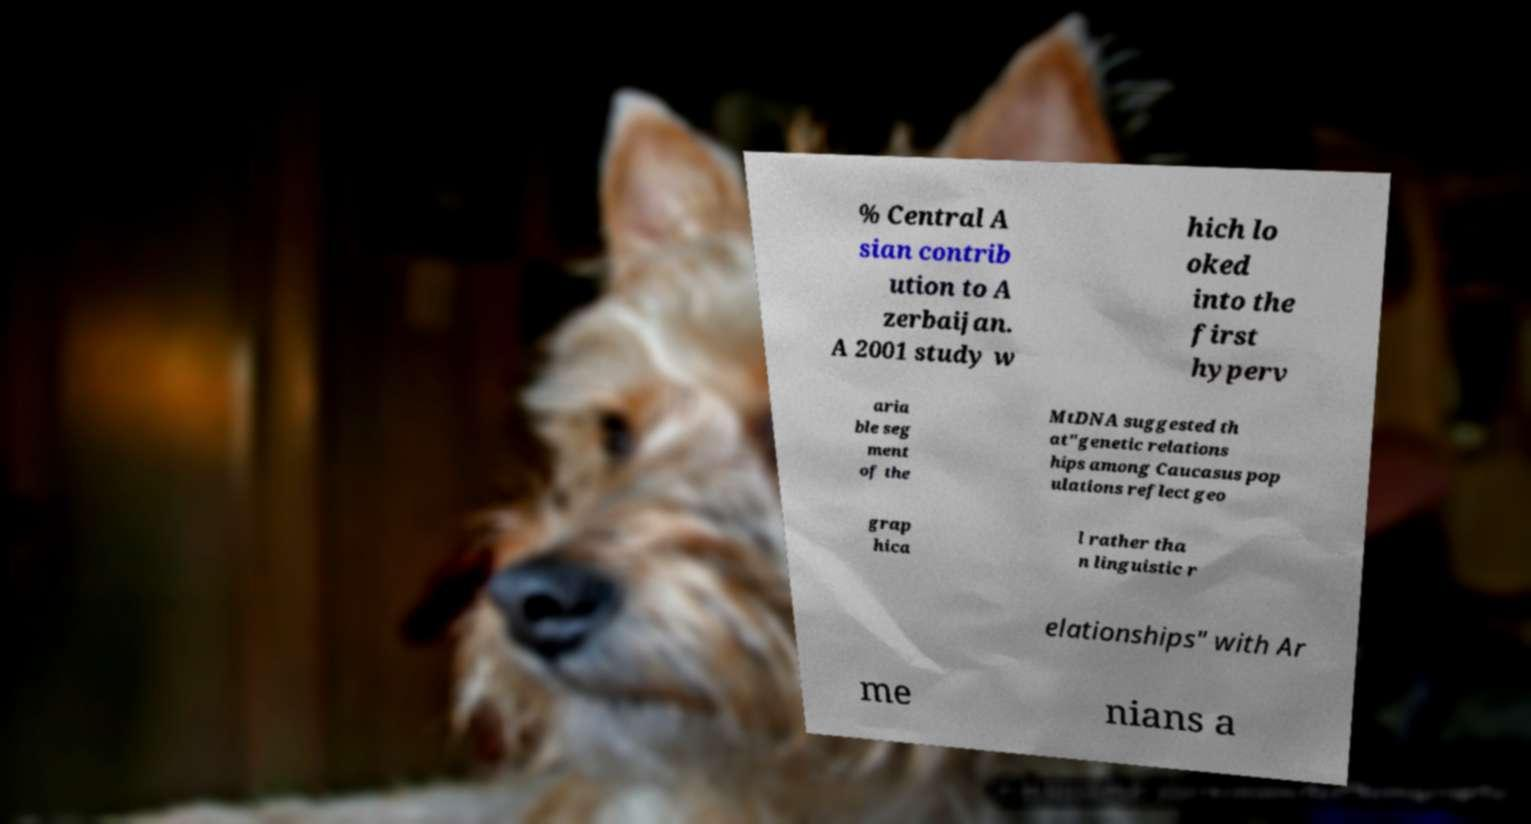Could you extract and type out the text from this image? % Central A sian contrib ution to A zerbaijan. A 2001 study w hich lo oked into the first hyperv aria ble seg ment of the MtDNA suggested th at"genetic relations hips among Caucasus pop ulations reflect geo grap hica l rather tha n linguistic r elationships" with Ar me nians a 